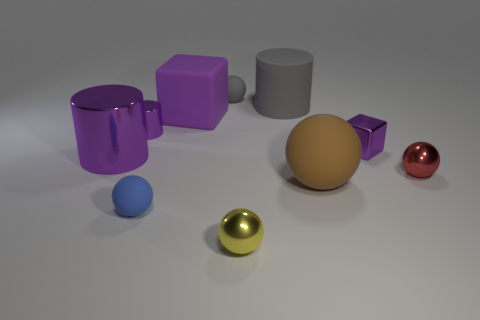Subtract all cyan spheres. Subtract all yellow cylinders. How many spheres are left? 5 Subtract all cubes. How many objects are left? 8 Subtract 2 purple cylinders. How many objects are left? 8 Subtract all big red rubber things. Subtract all small cubes. How many objects are left? 9 Add 7 large gray rubber things. How many large gray rubber things are left? 8 Add 2 tiny gray spheres. How many tiny gray spheres exist? 3 